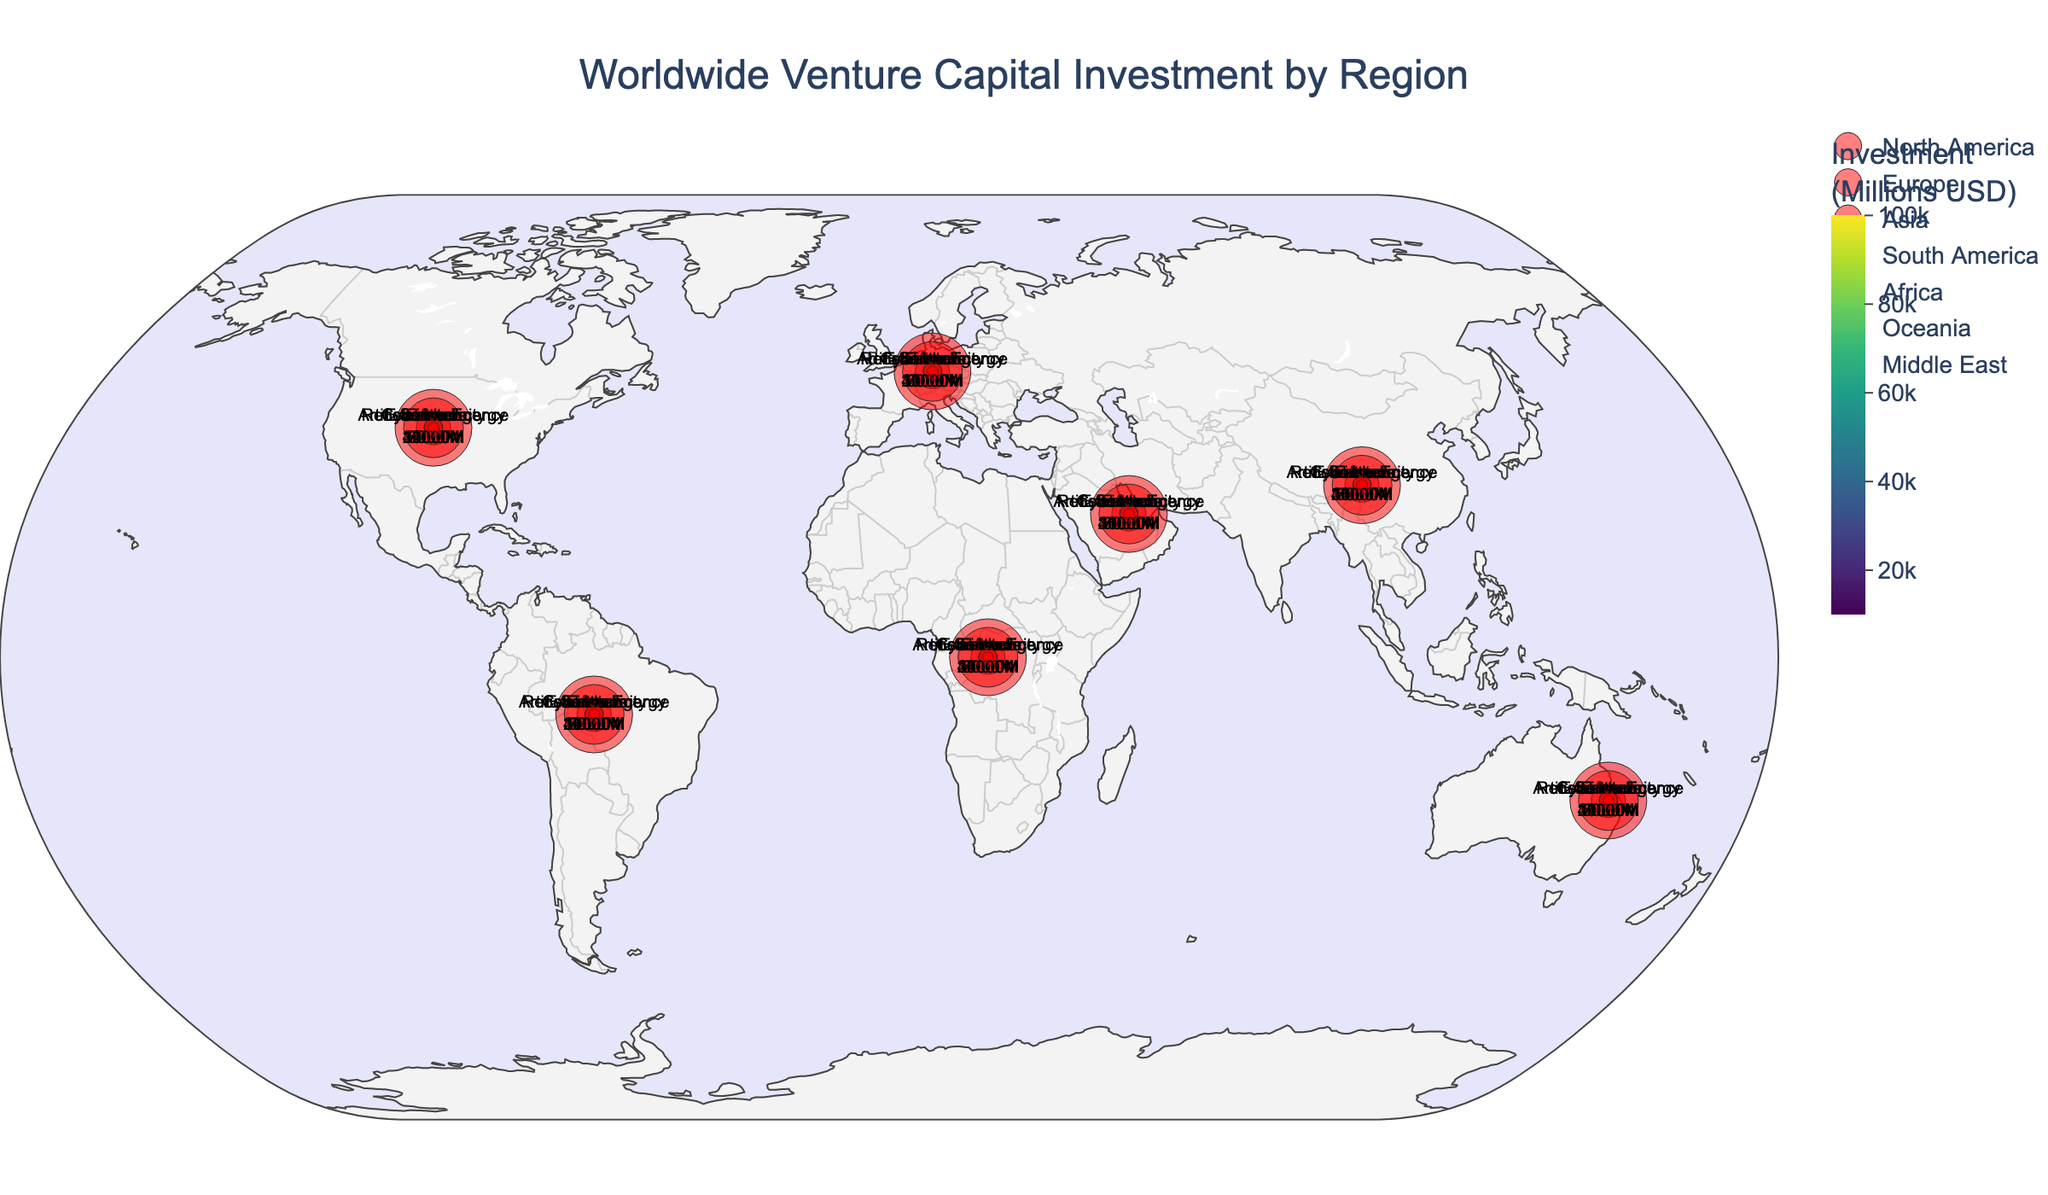what is the total venture capital investment in North America? From the figure, we can see the color intensity for North America which corresponds to the total investment. To get the exact amount, we refer to the color bar indicating the investment range that matches North America's color. By referring to the dataset, the total investment amount in North America is $100,000 million.
Answer: $100,000 million Which region received the highest venture capital investment? From the color differences on the map, we can assess the intensity of colors to determine which region saw the highest investment. North America appears to have the darkest color, indicating the highest venture capital investment.
Answer: North America What is the top industry in Europe based on venture capital investment? By examining the added marker bubbles, we can identify the top industry for each region. Europe's bubble displays: "Software - 20,000M".
Answer: Software Compare the venture capital investment in Biotech for North America and Healthtech for the Middle East. Which is higher? Referring to the marker bubbles for these regions, North America's bubble notes "Biotech - 25000M" while the Middle East's reads "Healthtech - 9000M". Comparing these, Biotech for North America is higher.
Answer: Biotech for North America What is the total venture capital investment for regions outside of North America? Summing the investments for all other regions: Europe (53000M), Asia (75000M), South America (18000M), Africa (12000M), Oceania (10000M), and Middle East (20000M), we get 188,000 million.
Answer: 188,000 million What type of technology has the highest investment in Asia? Reviewing the Asia marker bubbles, the bubble text lists "E-commerce - 35000M", revealing the highest investment in Asia.
Answer: E-commerce How does the venture capital investment in Cleantech in Europe compare with Fintech in South America? Looking at the marker bubbles for the respective regions, Europe’s bubble notes "Cleantech - 15000M" and South America’s shows "Fintech - 10000M". Cleantech in Europe is higher.
Answer: Cleantech in Europe Which region has the least total venture capital investment, and what is that amount? From the color intensity on the map and referring to the color bar, Africa appears to have the lightest color, indicating the lowest investment, which is $12,000 million.
Answer: Africa - $12,000 million 